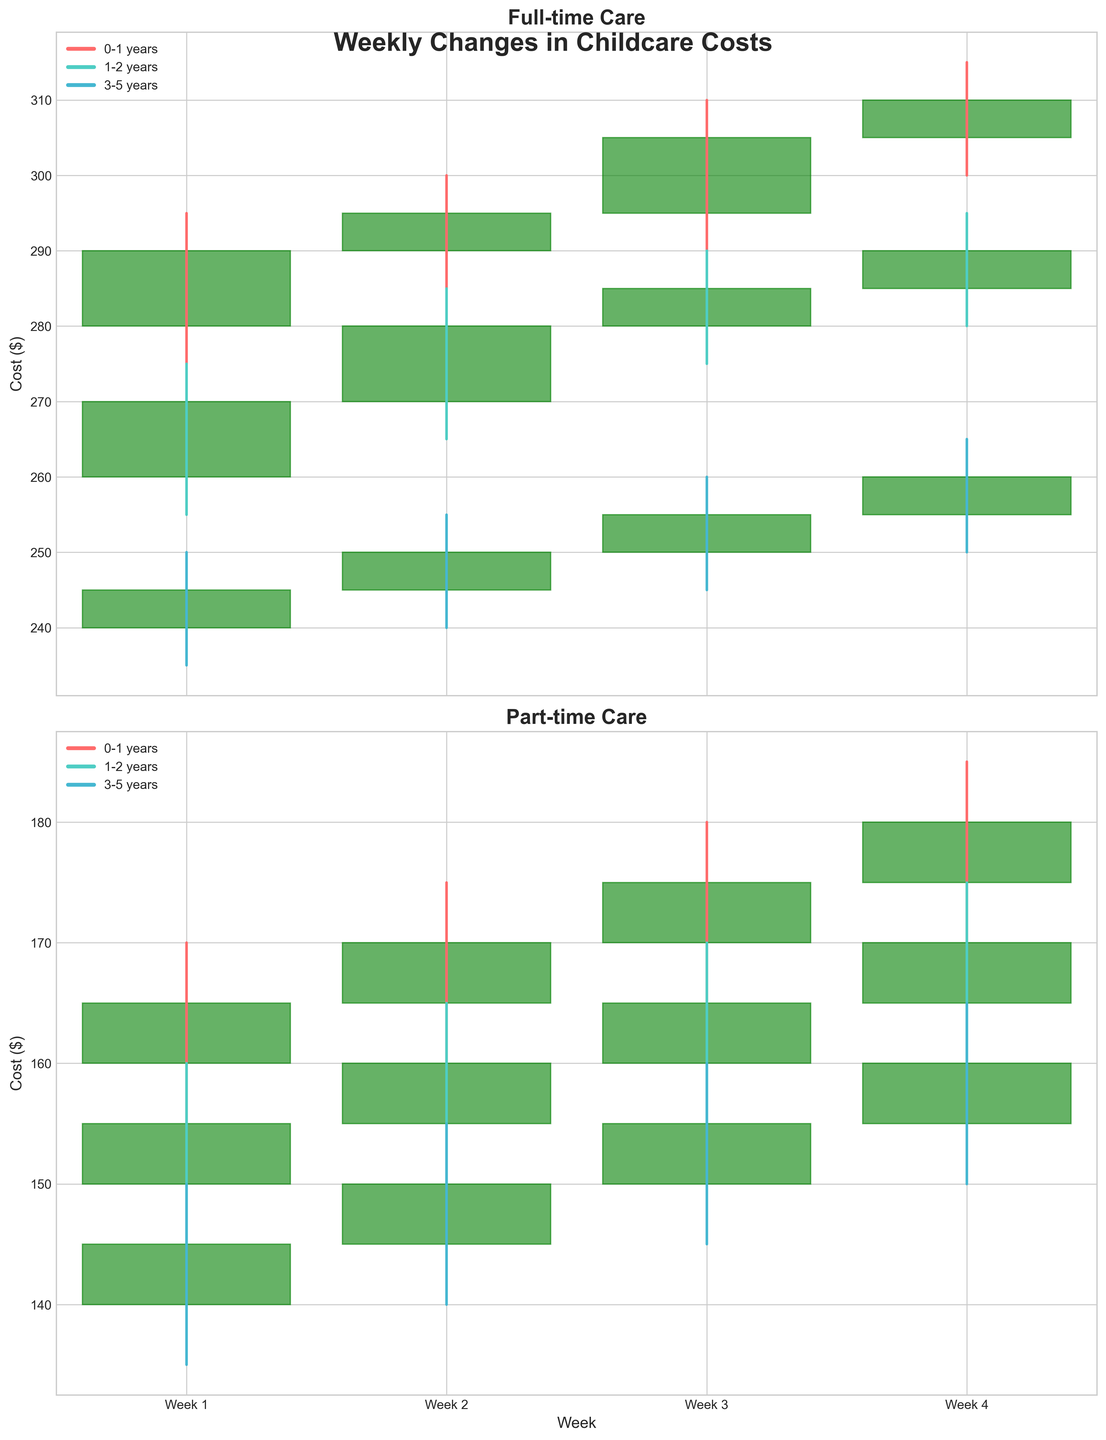What's the title of the figure? The title of the figure is located at the top and it tells us the main topic of the chart. In this case, the title is 'Weekly Changes in Childcare Costs'.
Answer: Weekly Changes in Childcare Costs Which age group has the highest cost for full-time care in Week 4? First, look at the Full-time section for Week 4. Identify which age group has the highest 'High' value. The 0-1 years age group reaches a high of 315 dollars.
Answer: 0-1 years By how much did the cost of full-time care for 1-2 years age group change from Week 1 to Week 4? Check the 'Close' values for 1-2 years full-time care in Week 1 and Week 4. The values are 270 and 290 respectively, so the change is 290 - 270 = 20 dollars.
Answer: 20 dollars Which care type has a wider range of costs for the 3-5 years age group in Week 2, full-time or part-time? For the 3-5 years age group in Week 2, look at the difference between 'High' and 'Low' for both care types. Full-time costs range from 255 to 240 (15 dollars), and part-time costs range from 155 to 140 (15 dollars). Both ranges are the same.
Answer: Both are the same Did the cost of part-time care for 1-2 years increase or decrease from Week 3 to Week 4? Compare the 'Close' values for part-time care in Weeks 3 and 4 for the 1-2 years age group. They are 165 and 170 respectively, so the cost increased.
Answer: Increased What is the average closing cost for full-time care in Week 3 across all age groups? Calculate the average by summing the 'Close' values for all age groups for full-time care in Week 3 and then dividing by the number of age groups. The values are 305 (0-1 years), 285 (1-2 years), and 255 (3-5 years). So, (305 + 285 + 255) / 3 = 845 / 3 = 281.67 dollars.
Answer: 281.67 dollars Which age group had the lowest opening cost for part-time care in any week? Look for the smallest 'Open' value in the part-time care section across all weeks and age groups. The lowest opening value is 140 for the 3-5 years age group in Week 1.
Answer: 3-5 years Did any age group's full-time care cost decrease at any point during the 4-week period? For each age group in full-time care, check if any 'Close' value is less than the 'Open' value for that week. For 0-1 years, 1-2 years, and 3-5 years, no week has a 'Close' value less than the 'Open'. Thus, no age group's cost decreased.
Answer: No What was the closing cost for part-time care in Week 1 across all age groups? Check the 'Close' values for part-time care in Week 1 for all age groups: 165 (0-1 years), 155 (1-2 years), and 145 (3-5 years).
Answer: 165, 155, 145 dollars 